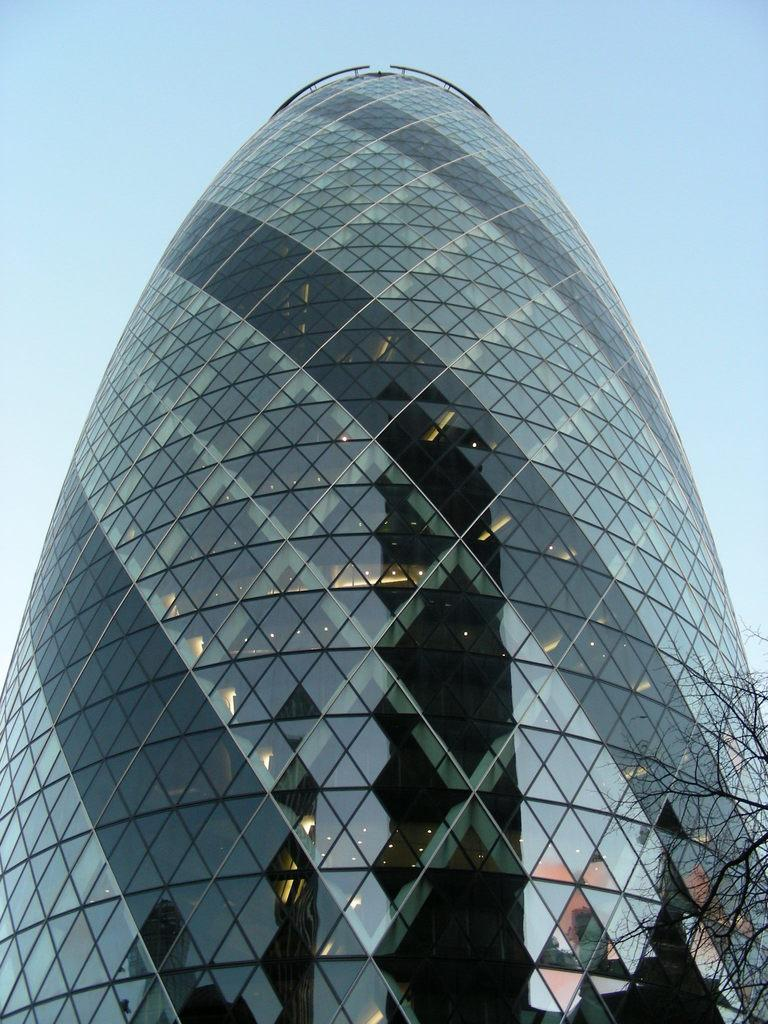What type of structure is depicted in the image? There is an architecture building in the image. What can be seen on the right side of the image? There is a tree on the right side of the image. What is visible behind the building in the image? The sky is visible behind the building. Is there a garden in the image where the goose is competing with other animals? There is no garden or goose present in the image, and no competition is depicted. 